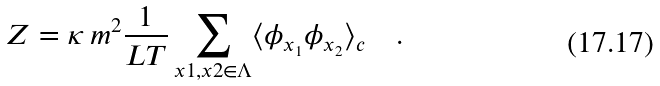<formula> <loc_0><loc_0><loc_500><loc_500>Z = \kappa \, m ^ { 2 } \frac { 1 } { L T } \sum _ { x 1 , x 2 \in \Lambda } \langle \phi _ { x _ { 1 } } \phi _ { x _ { 2 } } \rangle _ { c } \quad .</formula> 